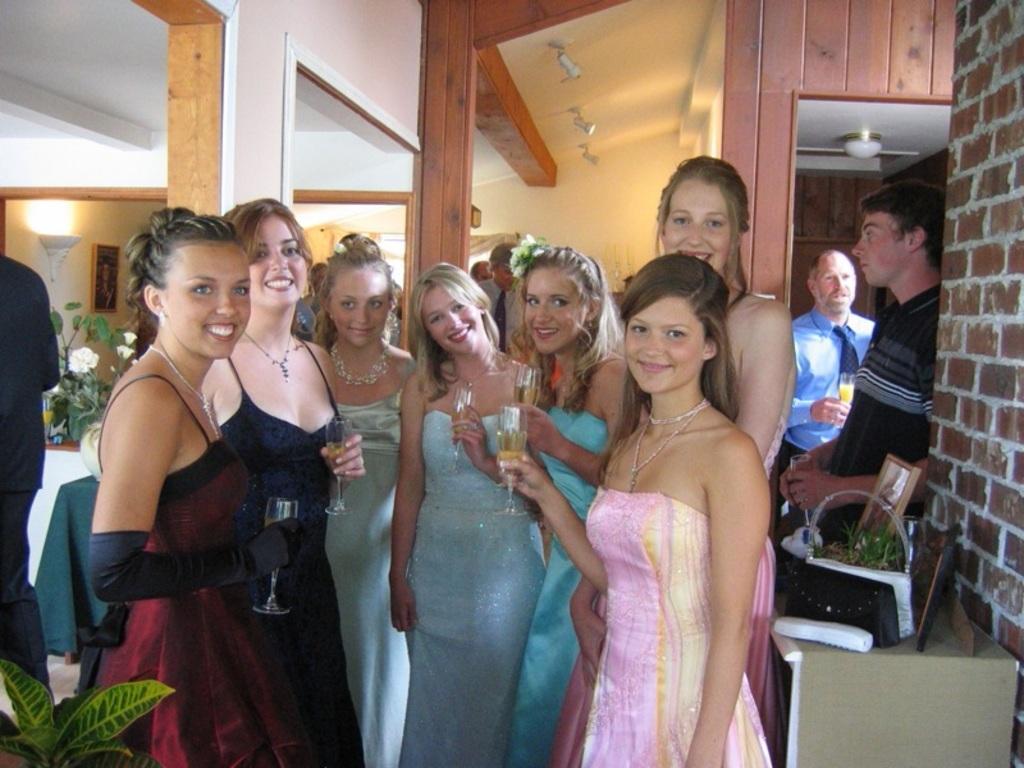Describe this image in one or two sentences. In this image I can see group of people standing and holding glasses. Back I can see pillars,wall,plants,light and few objects on the table. The frame is attached to the wall. 